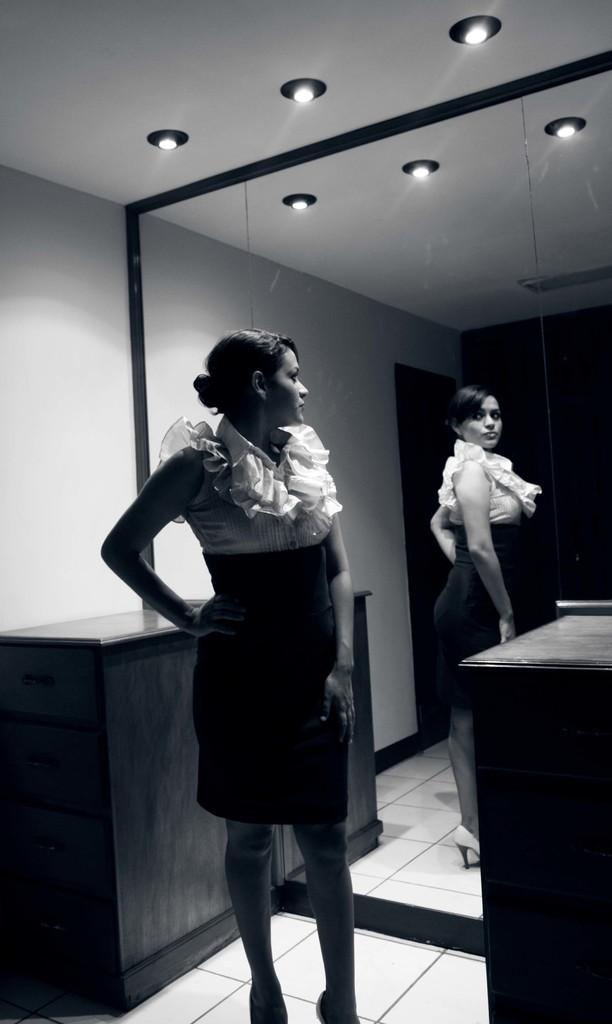Who is present in the image? There is a woman in the image. What is the woman doing in the image? The woman is standing in front of a mirror. What can be seen behind the woman? There is a cupboard behind the woman. What type of lighting is present in the image? There are lights on the ceiling in the image. How does the woman wash the sand off her hands in the image? There is no sand present in the image, and therefore no washing of sand can be observed. 